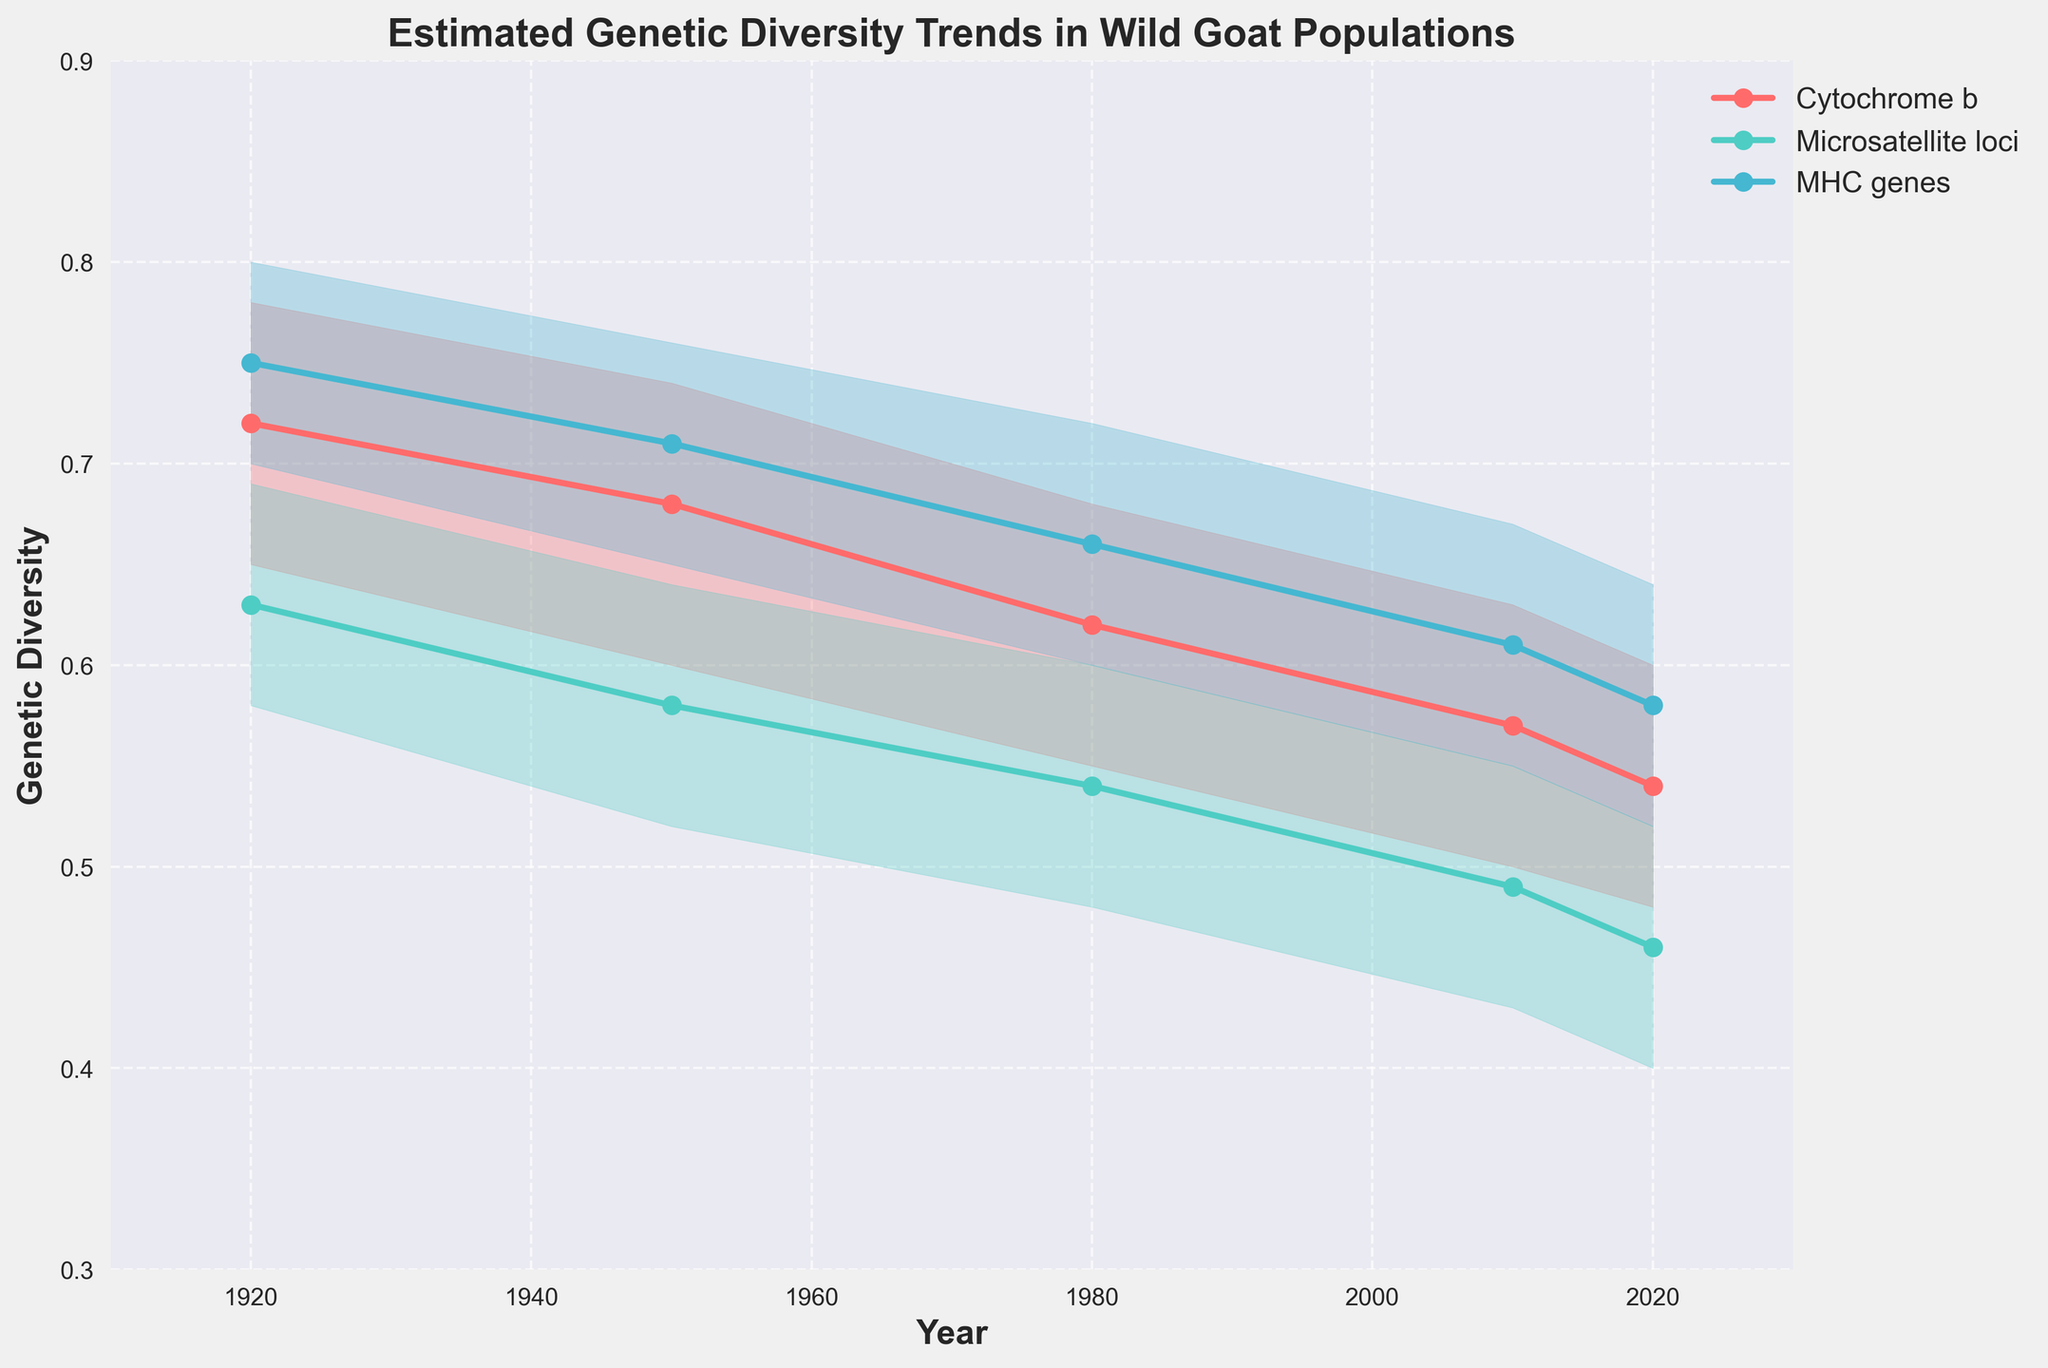What is the title of the figure? The title is prominently displayed at the top of the figure and reads "Estimated Genetic Diversity Trends in Wild Goat Populations."
Answer: Estimated Genetic Diversity Trends in Wild Goat Populations Over what range of years does the data in the plot extend? The x-axis of the plot shows years, and the range extends from 1910 to 2030.
Answer: 1910 to 2030 Which genetic marker shows the highest likely estimated genetic diversity in 2020? Looking at the points plotted for 2020, the MHC genes show the highest likely estimated genetic diversity, marked by the highest point on the y-axis at 0.58.
Answer: MHC genes How does the likely estimated genetic diversity for Cytochrome b change from 1920 to 2020? The likely estimated genetic diversity for Cytochrome b decreases from 0.72 in 1920 to 0.54 in 2020.
Answer: Decreases What is the range of the estimated genetic diversity for Microsatellite loci in 2010? For 2010, the plot shows Microsatellite loci with a lower bound of 0.43 and an upper bound of 0.55, giving a range from 0.43 to 0.55.
Answer: 0.43 to 0.55 Compare the trends of the likely estimated genetic diversity between the three markers from 1920 to 2020. Which one shows the steepest decline? By observing the slopes of the likely estimates, Cytochrome b shows a decline from 0.72 to 0.54, Microsatellite loci from 0.63 to 0.46, and MHC genes from 0.75 to 0.58. Microsatellite loci shows the steepest decline.
Answer: Microsatellite loci What is the average likely estimated genetic diversity for MHC genes over all the years shown? The likely values for MHC genes are 0.75 (1920), 0.71 (1950), 0.66 (1980), 0.61 (2010), and 0.58 (2020). The average is calculated as (0.75 + 0.71 + 0.66 + 0.61 + 0.58) / 5 = 0.662.
Answer: 0.662 Which genetic marker had the smallest range of estimated genetic diversity in 1950? The ranges in 1950 for Cytochrome b are 0.60 to 0.74, for Microsatellite loci 0.52 to 0.64, and for MHC genes 0.65 to 0.76. The smallest range is for Microsatellite loci with 0.12.
Answer: Microsatellite loci What is the general trend observed in the genetic diversity for all markers from 1920 to 2020? All markers show a decreasing trend in their likely estimated genetic diversity from 1920 to 2020.
Answer: Decreasing 